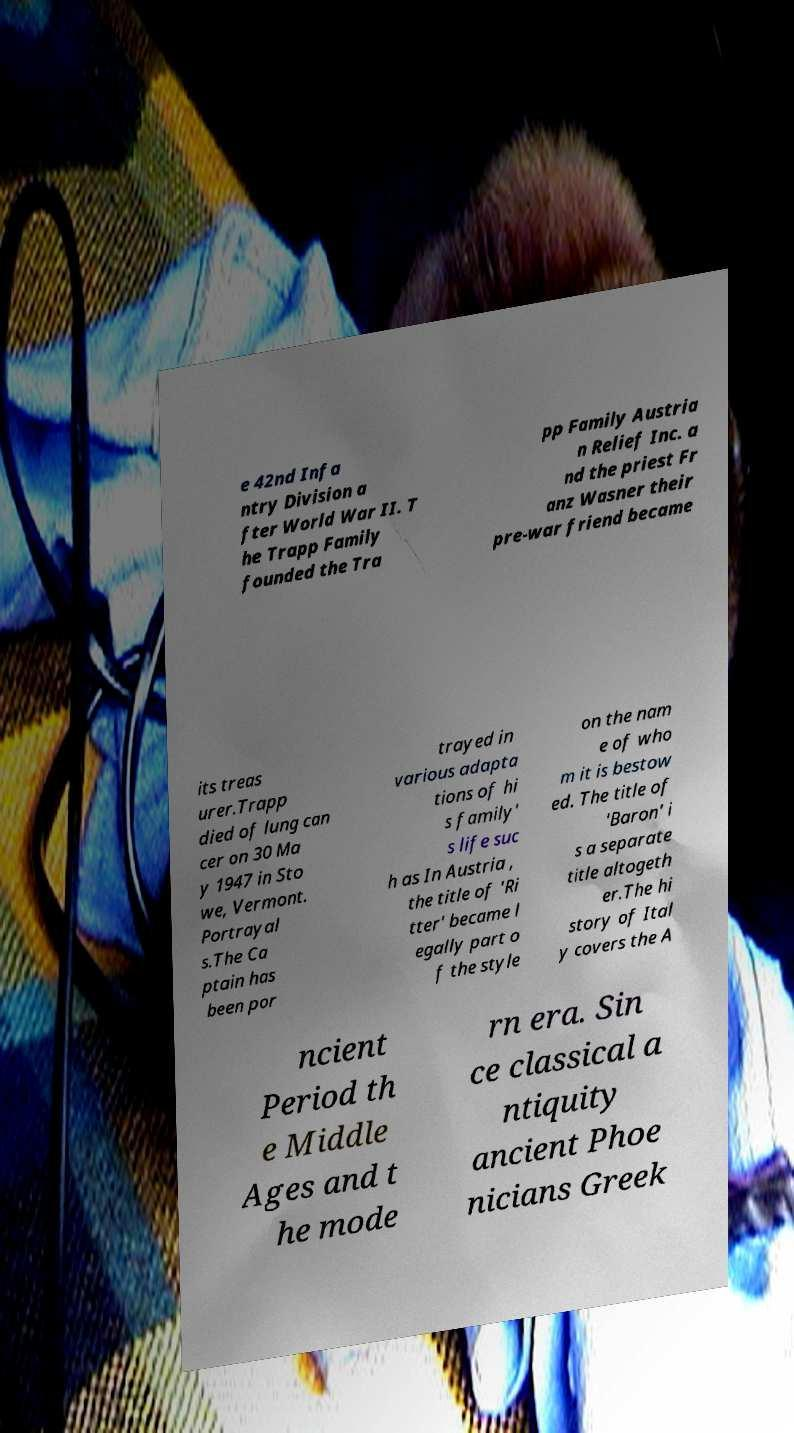Can you accurately transcribe the text from the provided image for me? e 42nd Infa ntry Division a fter World War II. T he Trapp Family founded the Tra pp Family Austria n Relief Inc. a nd the priest Fr anz Wasner their pre-war friend became its treas urer.Trapp died of lung can cer on 30 Ma y 1947 in Sto we, Vermont. Portrayal s.The Ca ptain has been por trayed in various adapta tions of hi s family' s life suc h as In Austria , the title of 'Ri tter' became l egally part o f the style on the nam e of who m it is bestow ed. The title of 'Baron' i s a separate title altogeth er.The hi story of Ital y covers the A ncient Period th e Middle Ages and t he mode rn era. Sin ce classical a ntiquity ancient Phoe nicians Greek 